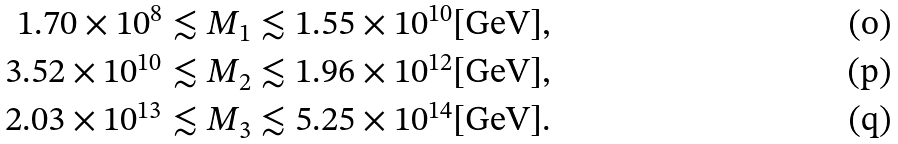Convert formula to latex. <formula><loc_0><loc_0><loc_500><loc_500>1 . 7 0 \times 1 0 ^ { 8 } & \lesssim M _ { 1 } \lesssim 1 . 5 5 \times 1 0 ^ { 1 0 } \text {[GeV]} , \\ 3 . 5 2 \times 1 0 ^ { 1 0 } & \lesssim M _ { 2 } \lesssim 1 . 9 6 \times 1 0 ^ { 1 2 } \text {[GeV]} , \\ 2 . 0 3 \times 1 0 ^ { 1 3 } & \lesssim M _ { 3 } \lesssim 5 . 2 5 \times 1 0 ^ { 1 4 } \text {[GeV]} .</formula> 